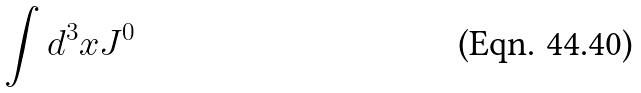Convert formula to latex. <formula><loc_0><loc_0><loc_500><loc_500>\int d ^ { 3 } x J ^ { 0 }</formula> 